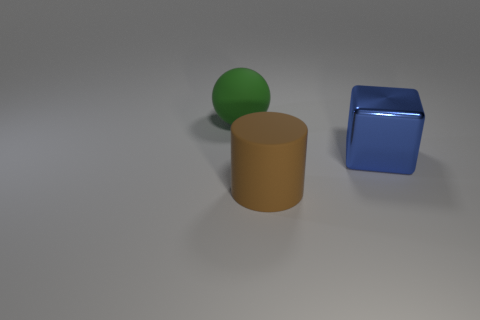Is the number of cylinders greater than the number of tiny yellow things?
Your answer should be very brief. Yes. There is a rubber object to the left of the rubber object in front of the big green rubber ball that is behind the large brown cylinder; how big is it?
Your response must be concise. Large. There is a cylinder that is in front of the large shiny thing; what size is it?
Make the answer very short. Large. How many things are either large rubber things or large rubber things in front of the big green ball?
Your answer should be compact. 2. How many other objects are the same size as the green rubber thing?
Provide a succinct answer. 2. Is the number of matte things that are behind the big metal object greater than the number of big cyan matte cubes?
Provide a succinct answer. Yes. Are there any other things that are the same color as the matte sphere?
Offer a terse response. No. What is the shape of the large green object that is made of the same material as the cylinder?
Your answer should be very brief. Sphere. Does the object in front of the metal cube have the same material as the large cube?
Give a very brief answer. No. What number of large things are right of the large sphere and to the left of the big blue metallic thing?
Offer a very short reply. 1. 